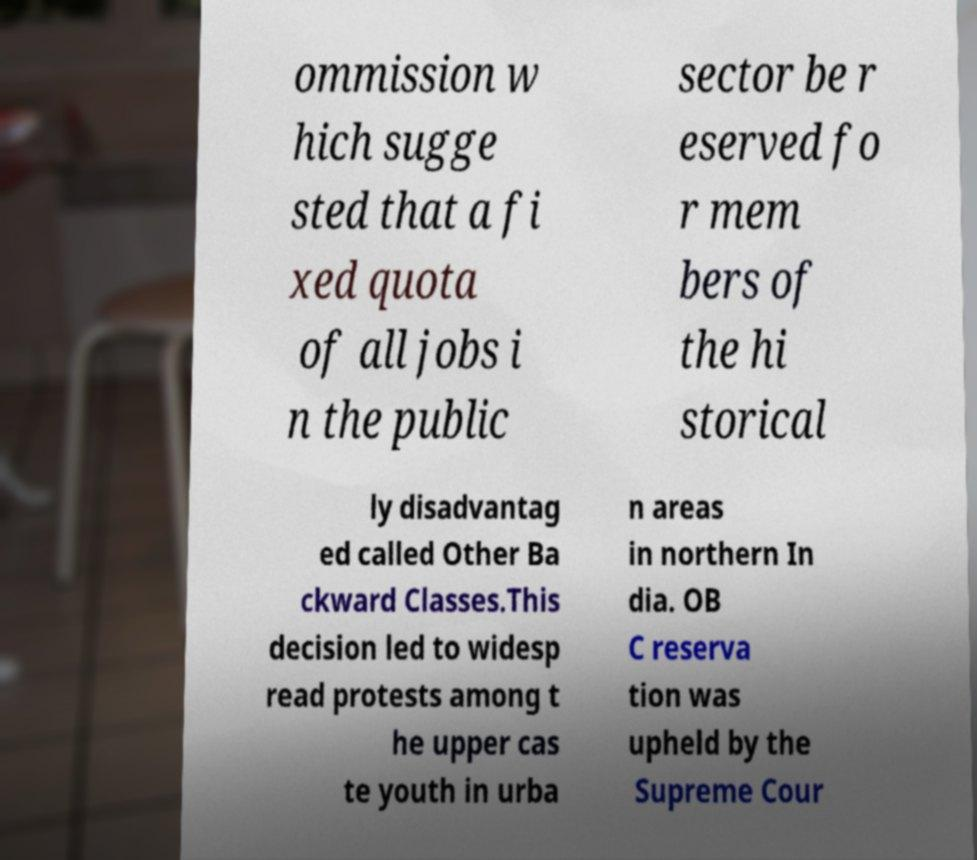Could you assist in decoding the text presented in this image and type it out clearly? ommission w hich sugge sted that a fi xed quota of all jobs i n the public sector be r eserved fo r mem bers of the hi storical ly disadvantag ed called Other Ba ckward Classes.This decision led to widesp read protests among t he upper cas te youth in urba n areas in northern In dia. OB C reserva tion was upheld by the Supreme Cour 